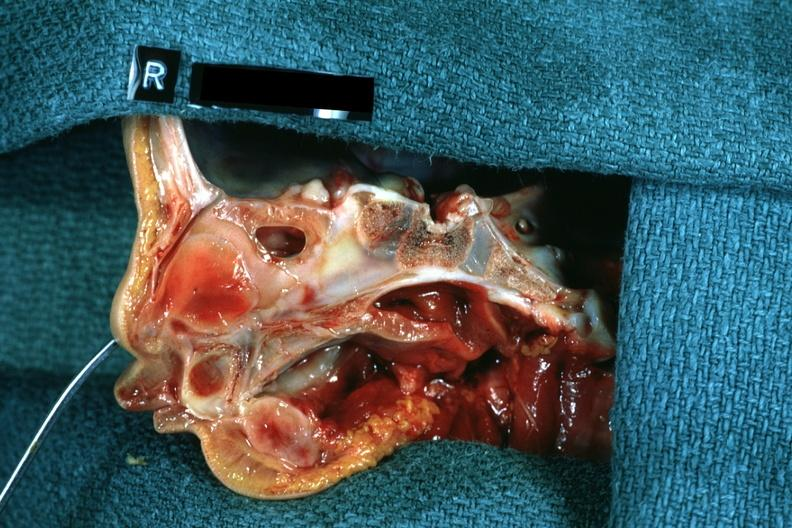what is present?
Answer the question using a single word or phrase. Choanal atresia 